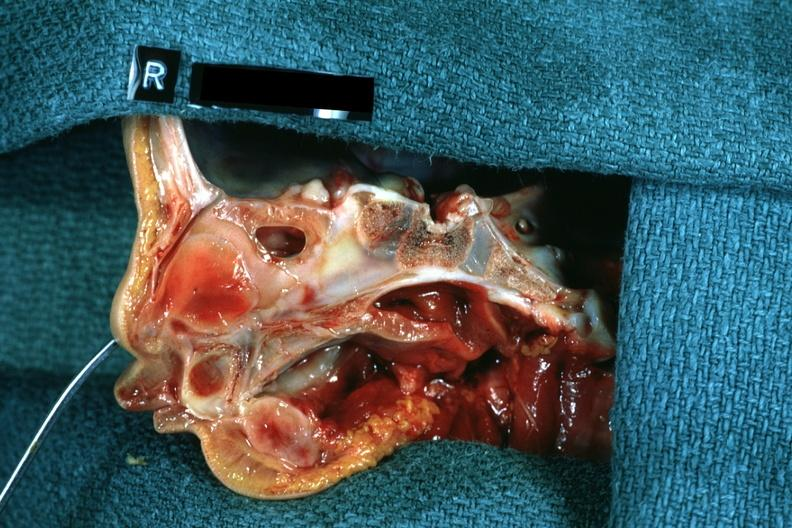what is present?
Answer the question using a single word or phrase. Choanal atresia 